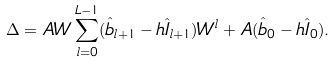<formula> <loc_0><loc_0><loc_500><loc_500>\Delta = A W \sum _ { l = 0 } ^ { L - 1 } ( \hat { b } _ { l + 1 } - h \hat { I } _ { l + 1 } ) W ^ { l } + A ( \hat { b } _ { 0 } - h \hat { I } _ { 0 } ) .</formula> 